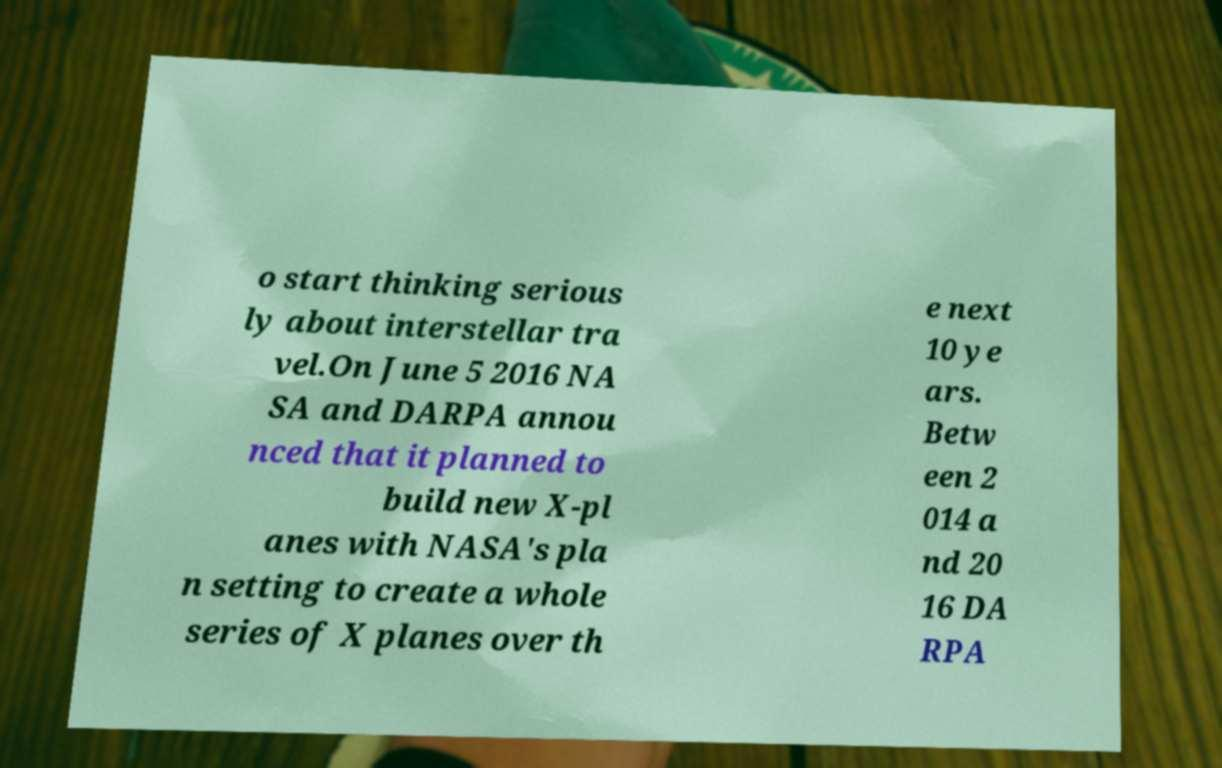Can you accurately transcribe the text from the provided image for me? o start thinking serious ly about interstellar tra vel.On June 5 2016 NA SA and DARPA annou nced that it planned to build new X-pl anes with NASA's pla n setting to create a whole series of X planes over th e next 10 ye ars. Betw een 2 014 a nd 20 16 DA RPA 